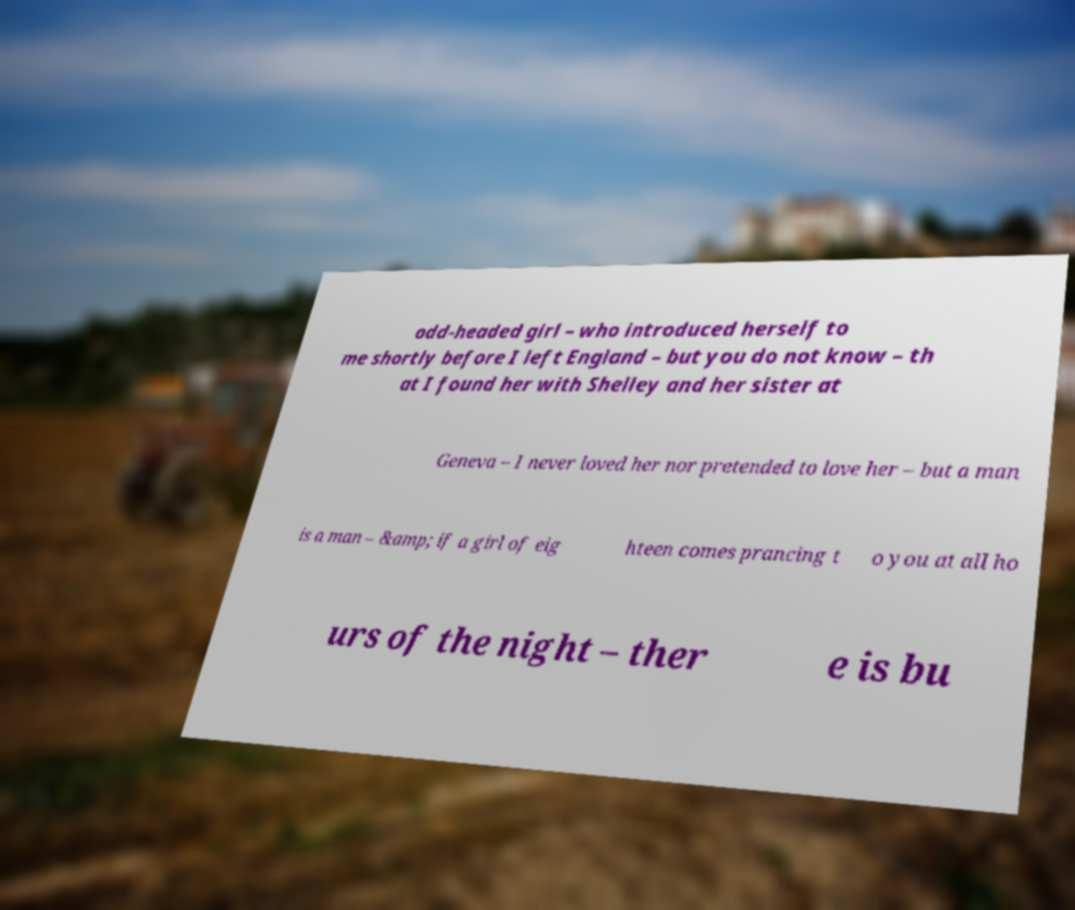There's text embedded in this image that I need extracted. Can you transcribe it verbatim? odd-headed girl – who introduced herself to me shortly before I left England – but you do not know – th at I found her with Shelley and her sister at Geneva – I never loved her nor pretended to love her – but a man is a man – &amp; if a girl of eig hteen comes prancing t o you at all ho urs of the night – ther e is bu 